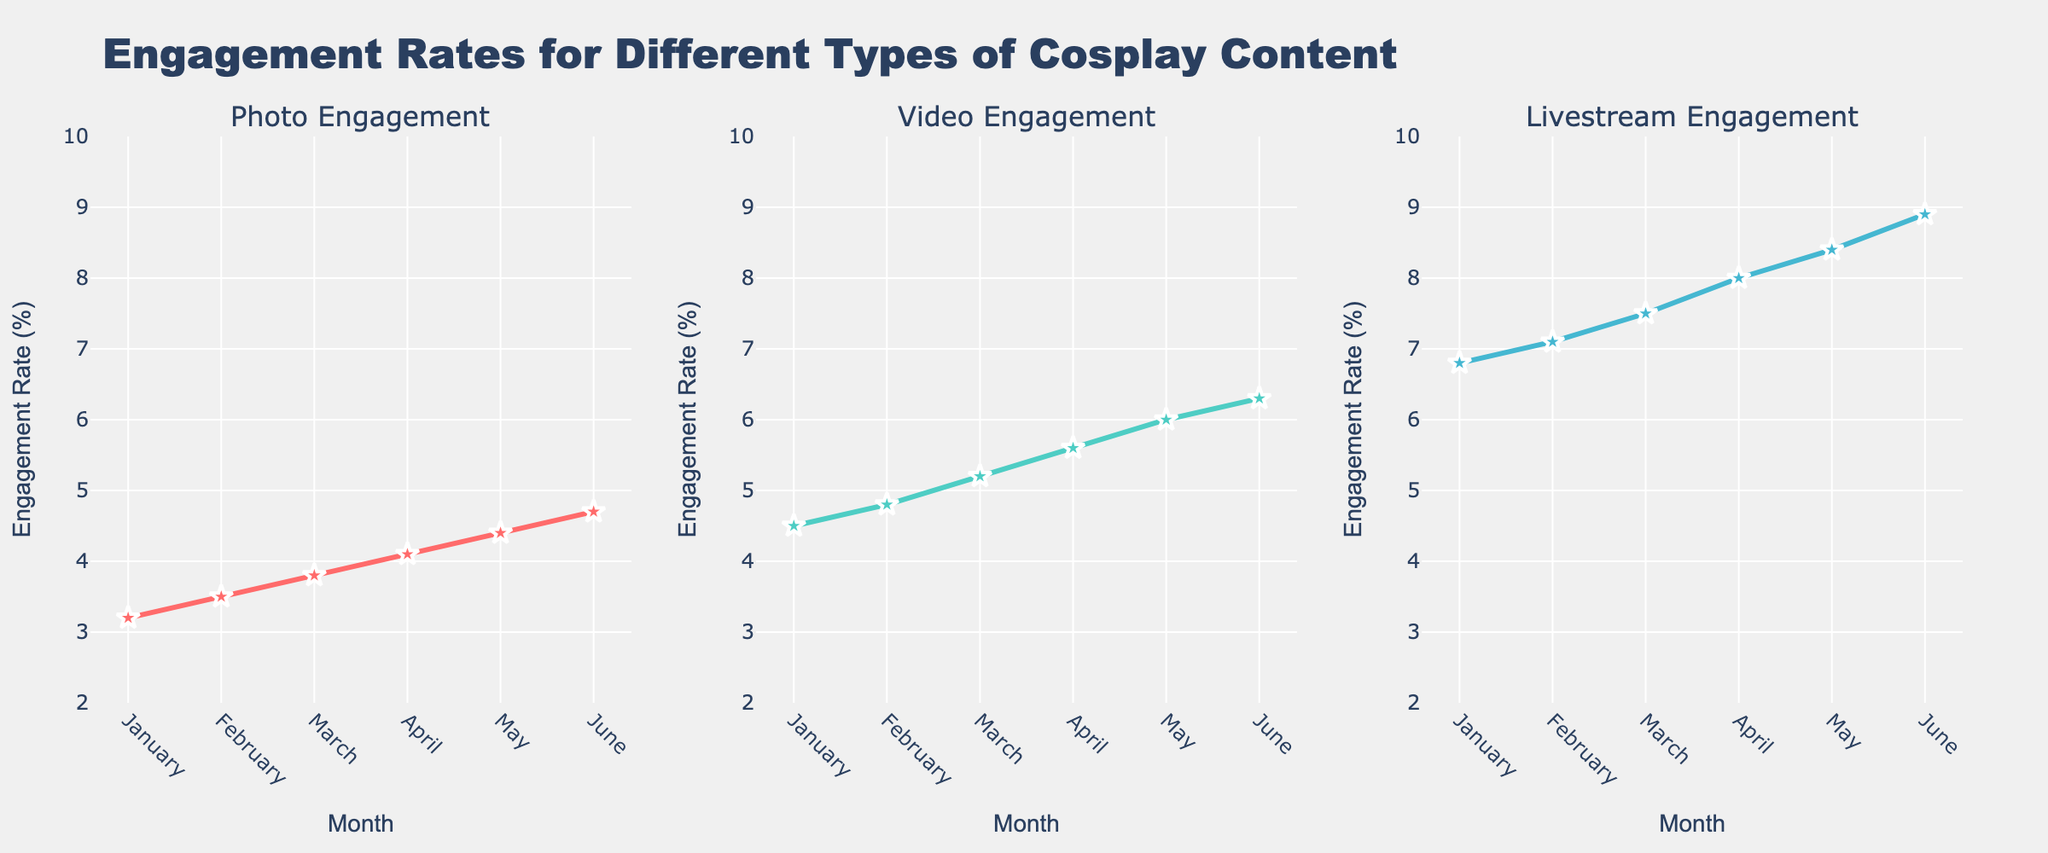What's the title of the figure? The title of the figure is located at the top and reads, "Engagement Rates for Different Types of Cosplay Content."
Answer: Engagement Rates for Different Types of Cosplay Content How many months are shown in the figure? Each subplot has data points along the x-axis labeled with months from "January" to "June." This means there are 6 months shown in the figure.
Answer: 6 Which type of content has the highest engagement rate in June? By observing the data points in June across all three subplots, the highest engagement rate is seen in the livestream category.
Answer: Livestream What is the engagement rate increase for photos from January to June? The engagement rate for photos in January is 3.2% and in June is 4.7%. The increase is calculated by subtracting January’s value from June’s value: 4.7% - 3.2% = 1.5%.
Answer: 1.5% What's the average engagement rate for videos over the 6 months? To find the average engagement rate for videos, sum the rates from January to June (4.5 + 4.8 + 5.2 + 5.6 + 6.0 + 6.3) and divide by 6. The total is 32.4, so the average is 32.4 / 6 ≈ 5.4%.
Answer: 5.4% Which month shows the largest increase in engagement rate for livestreams compared to the previous month? Calculate the difference in livestream engagement rates month-to-month and find the largest difference: February (7.1 - 6.8 = 0.3), March (7.5 - 7.1 = 0.4), April (8.0 - 7.5 = 0.5), May (8.4 - 8.0 = 0.4), June (8.9 - 8.4 = 0.5). The months of April and June show the largest increase of 0.5%.
Answer: April and June Which type of content has the steepest upward trend in engagement over the 6 months? By observing the slope of the lines in each subplot, the steepest upward trend is visible in the livestream subplot.
Answer: Livestream What is the difference in engagement rate between photos and videos in May? The engagement rate for photos in May is 4.4% and for videos is 6.0%. The difference is 6.0% - 4.4% = 1.6%.
Answer: 1.6% Which engagement type had the smallest increase over the 6-month period? Calculate the difference from January to June for each type: Photo: 4.7 - 3.2 = 1.5, Video: 6.3 - 4.5 = 1.8, Livestream: 8.9 - 6.8 = 2.1. The smallest increase is seen in photos.
Answer: Photos 